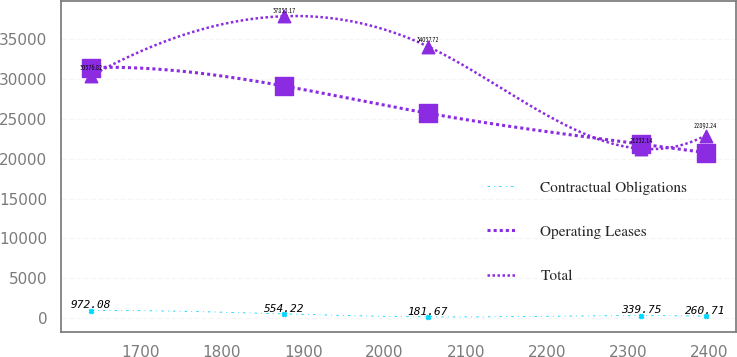<chart> <loc_0><loc_0><loc_500><loc_500><line_chart><ecel><fcel>Contractual Obligations<fcel>Operating Leases<fcel>Total<nl><fcel>1638.99<fcel>972.08<fcel>31408.8<fcel>30376.8<nl><fcel>1876.54<fcel>554.22<fcel>29087<fcel>37833.2<nl><fcel>2053.59<fcel>181.67<fcel>25680.8<fcel>34037.7<nl><fcel>2316.21<fcel>339.75<fcel>21817.9<fcel>21232.1<nl><fcel>2395.29<fcel>260.71<fcel>20752.2<fcel>22892.2<nl></chart> 